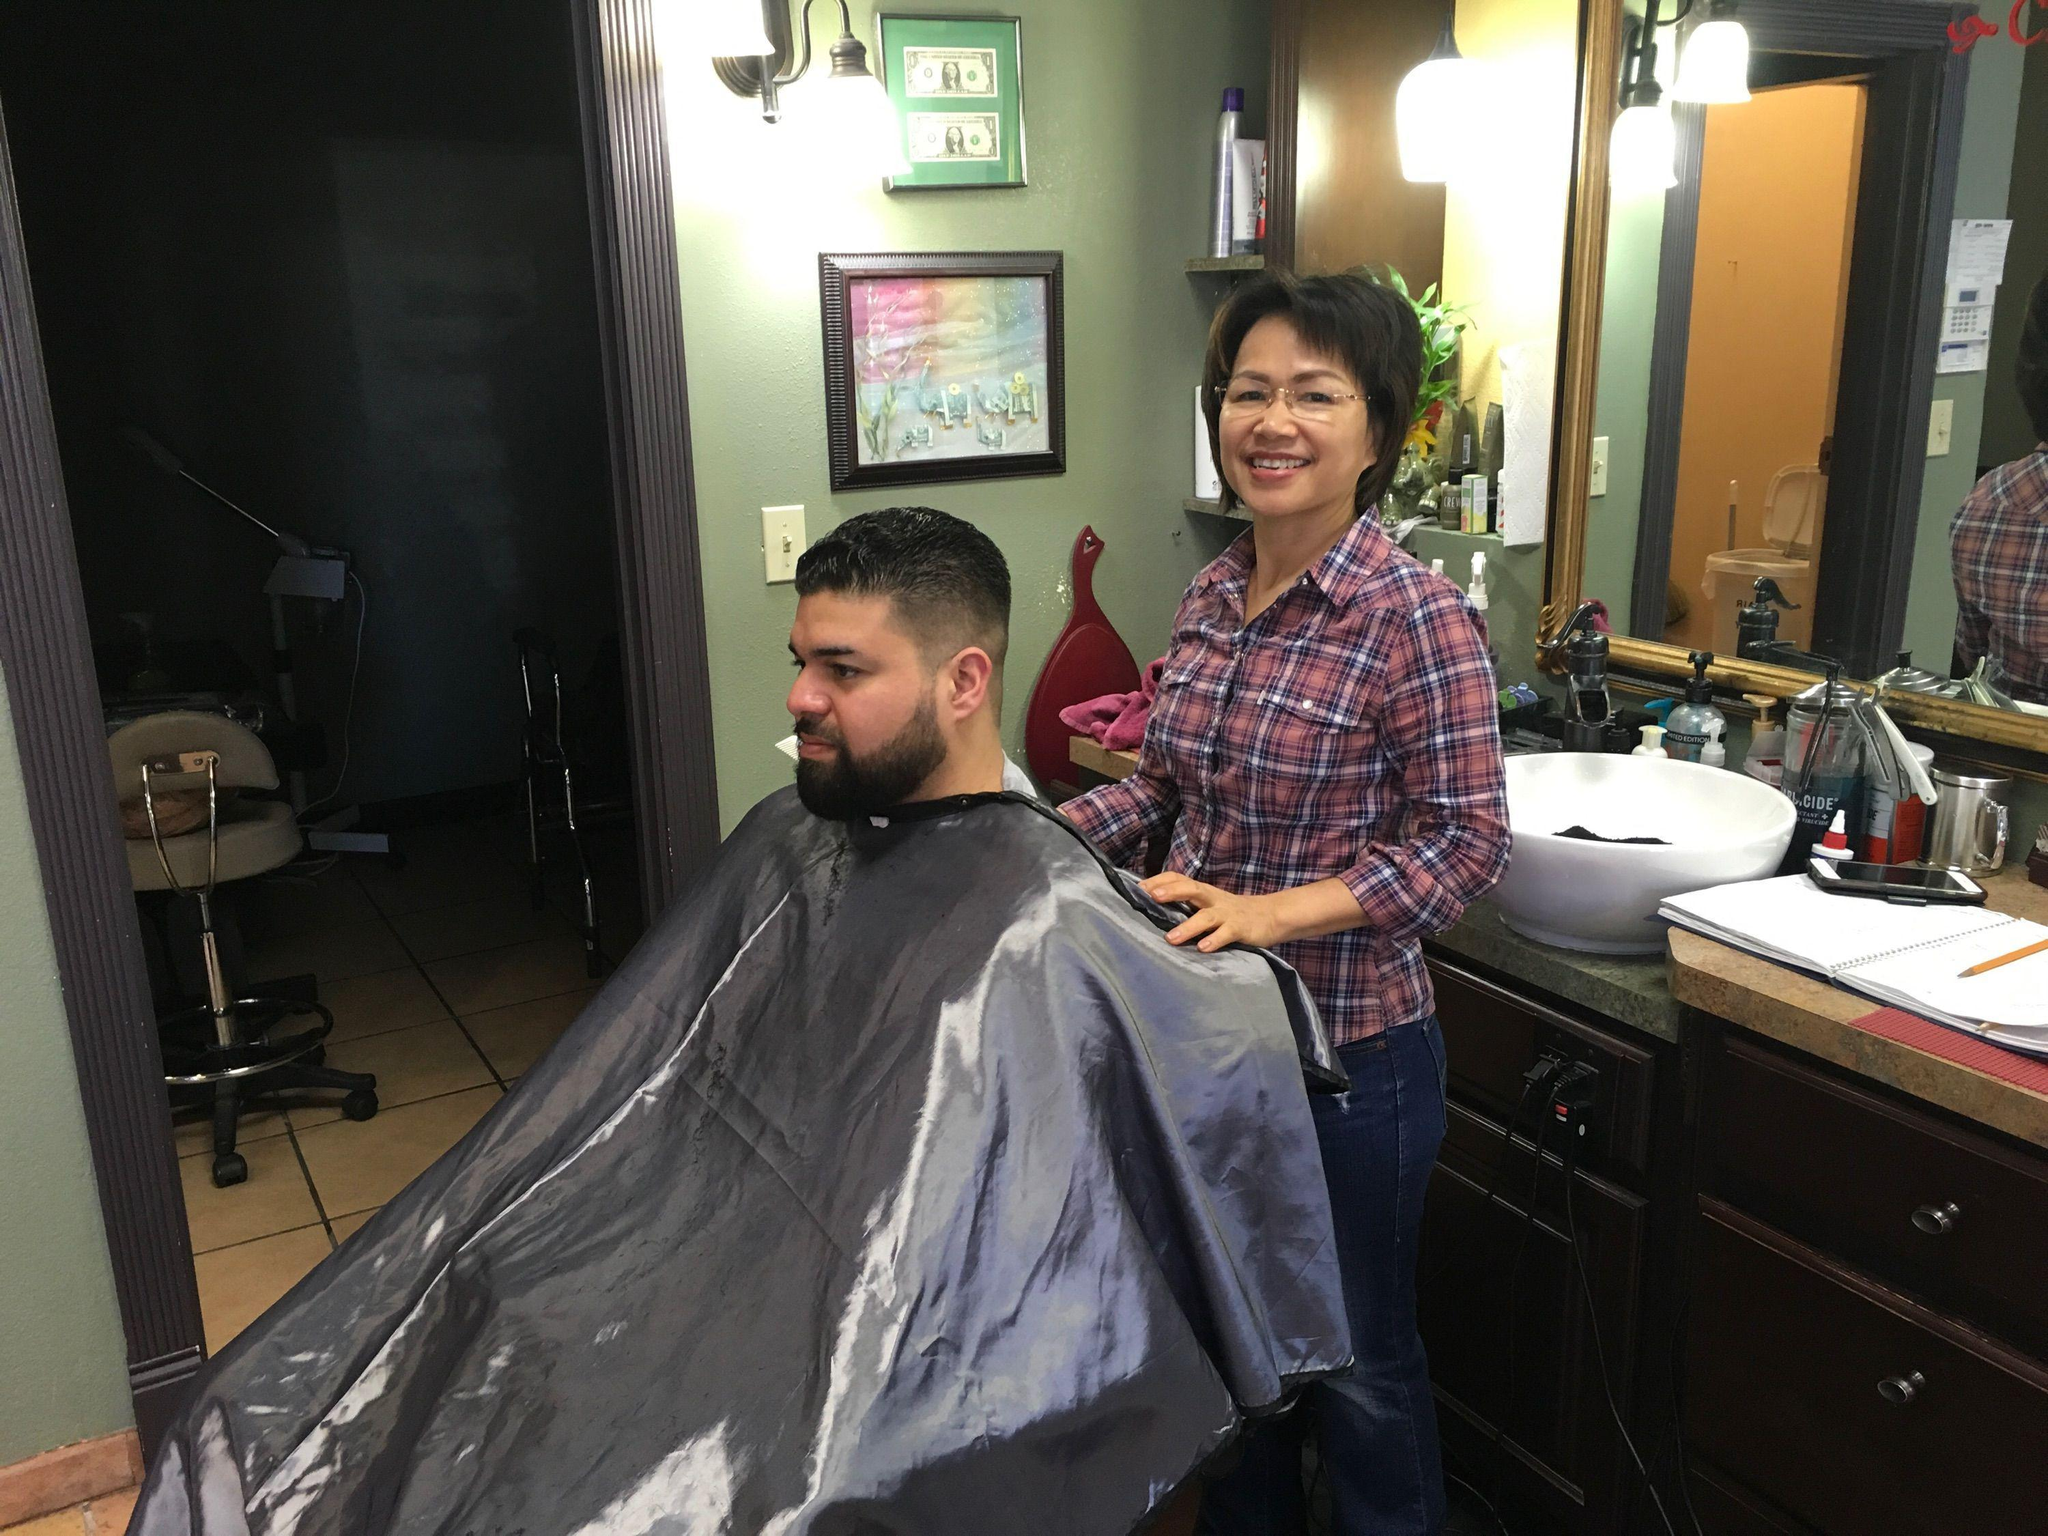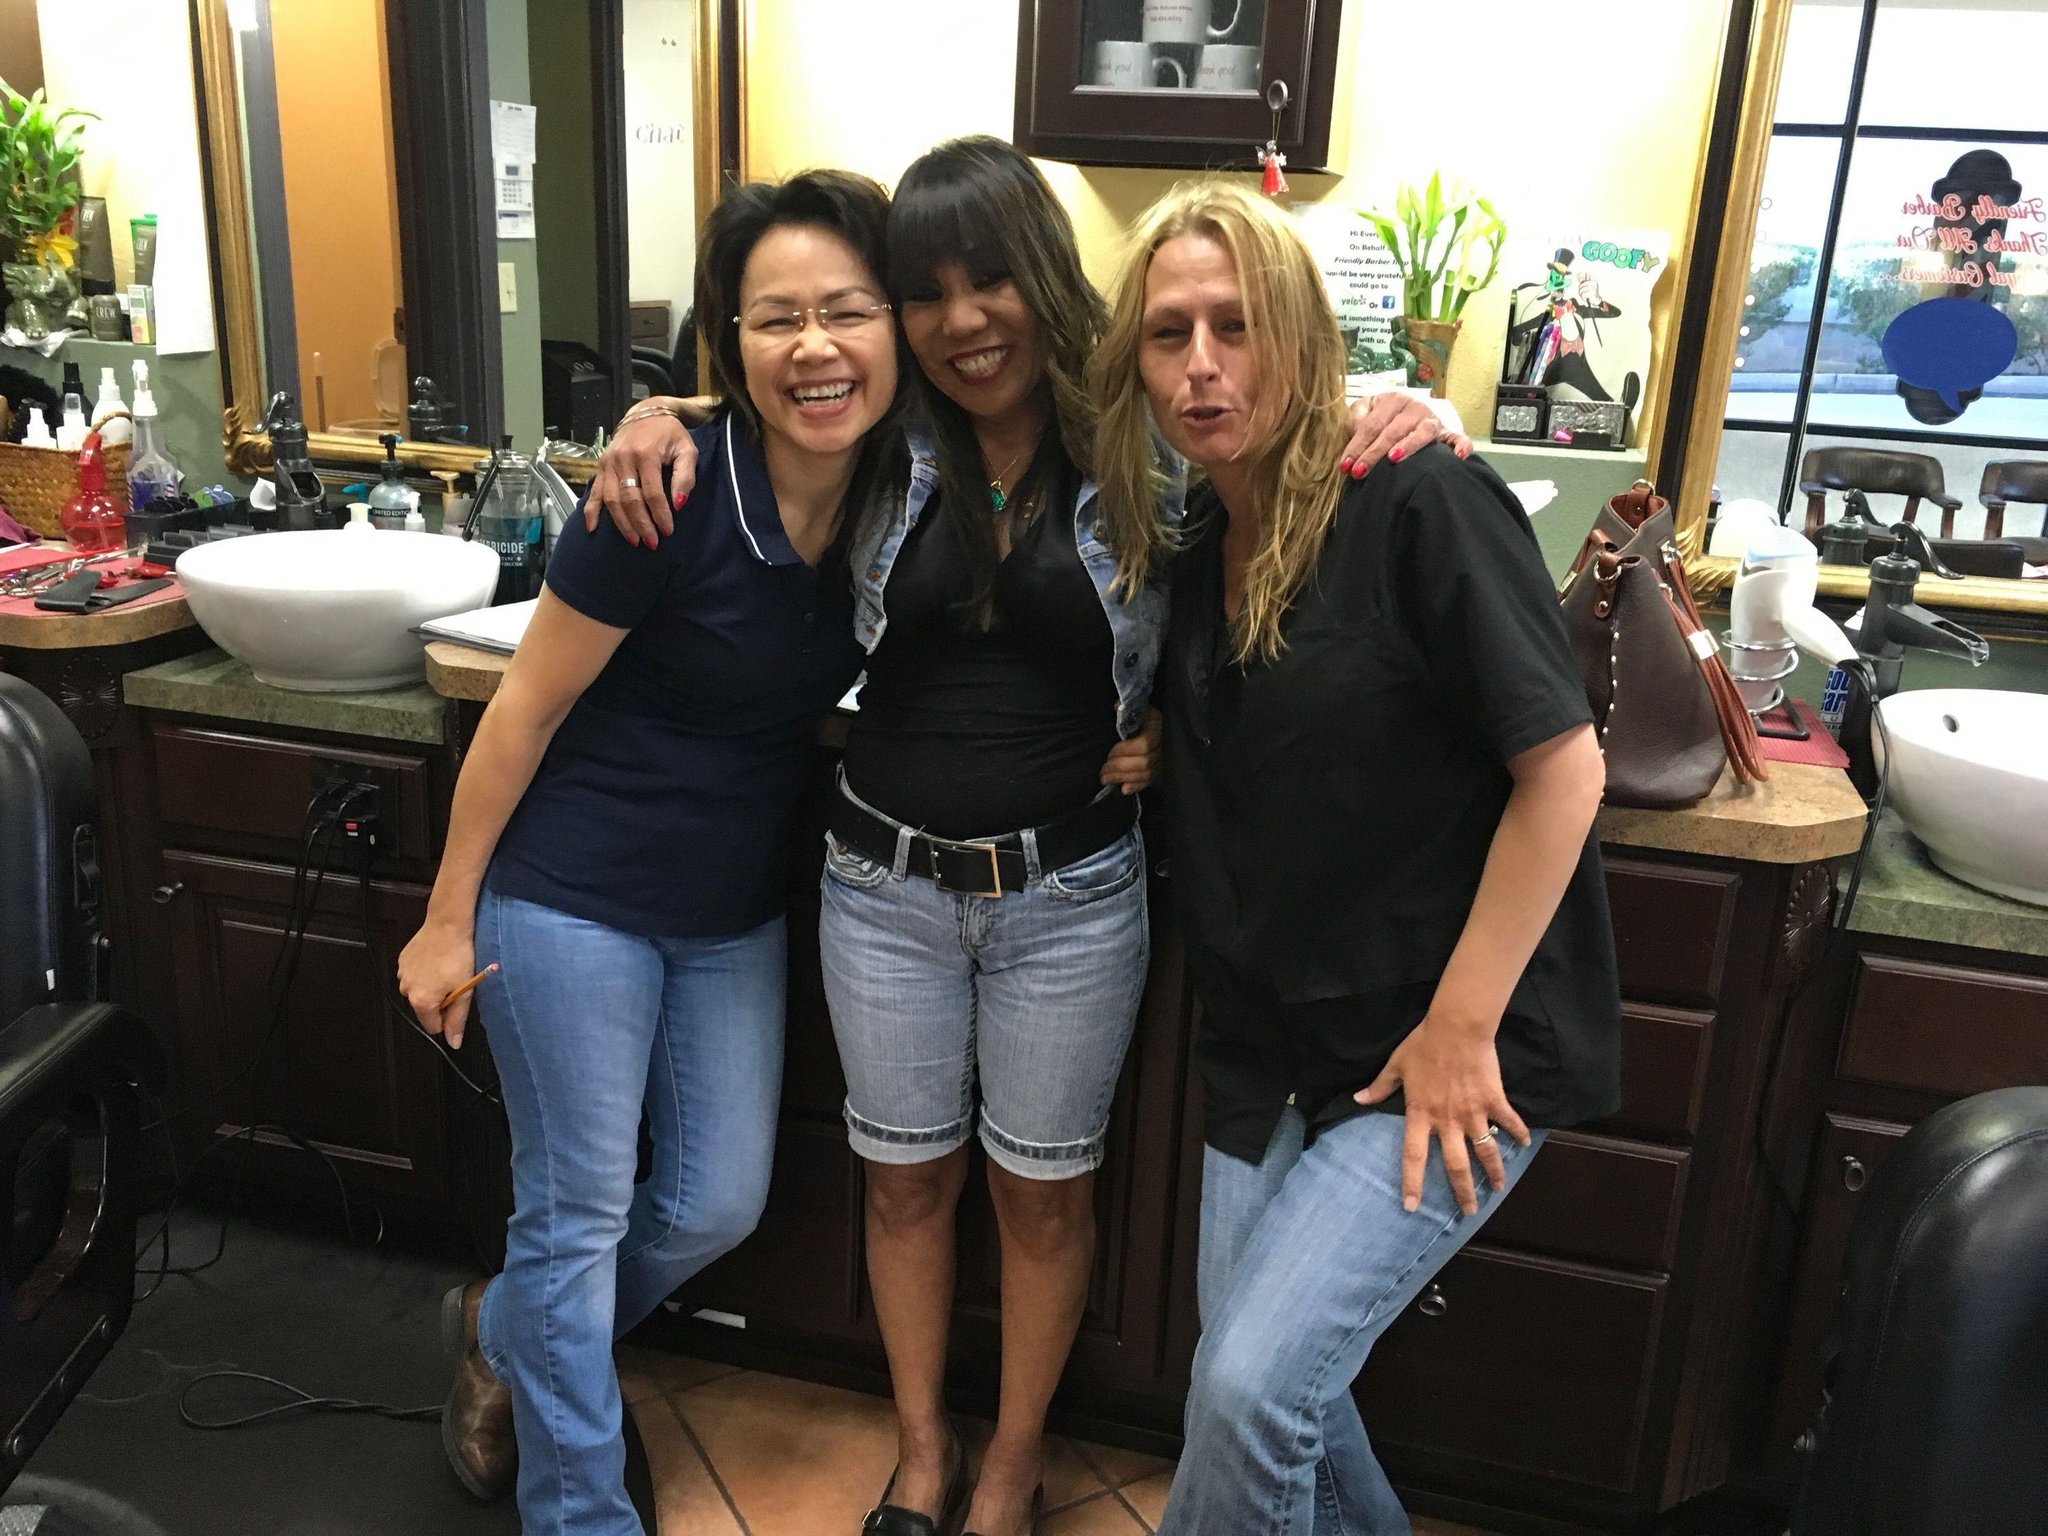The first image is the image on the left, the second image is the image on the right. For the images displayed, is the sentence "Five humans are visible." factually correct? Answer yes or no. Yes. The first image is the image on the left, the second image is the image on the right. Examine the images to the left and right. Is the description "There is a total of five people include the different image reflected in the mirror." accurate? Answer yes or no. Yes. 